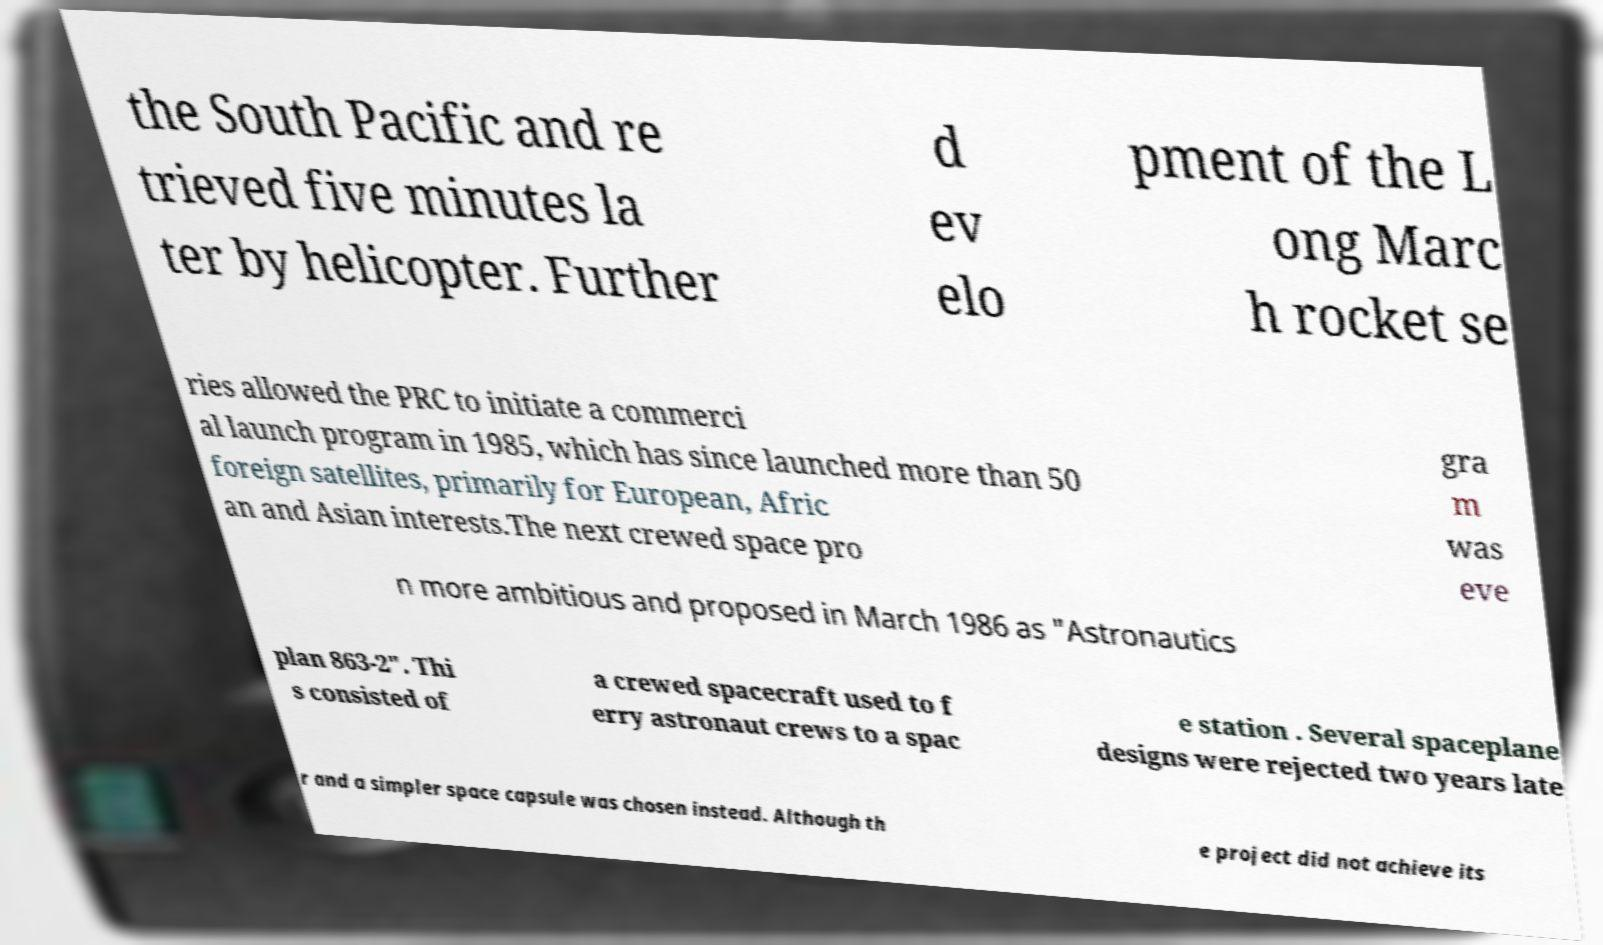Could you extract and type out the text from this image? the South Pacific and re trieved five minutes la ter by helicopter. Further d ev elo pment of the L ong Marc h rocket se ries allowed the PRC to initiate a commerci al launch program in 1985, which has since launched more than 50 foreign satellites, primarily for European, Afric an and Asian interests.The next crewed space pro gra m was eve n more ambitious and proposed in March 1986 as "Astronautics plan 863-2". Thi s consisted of a crewed spacecraft used to f erry astronaut crews to a spac e station . Several spaceplane designs were rejected two years late r and a simpler space capsule was chosen instead. Although th e project did not achieve its 